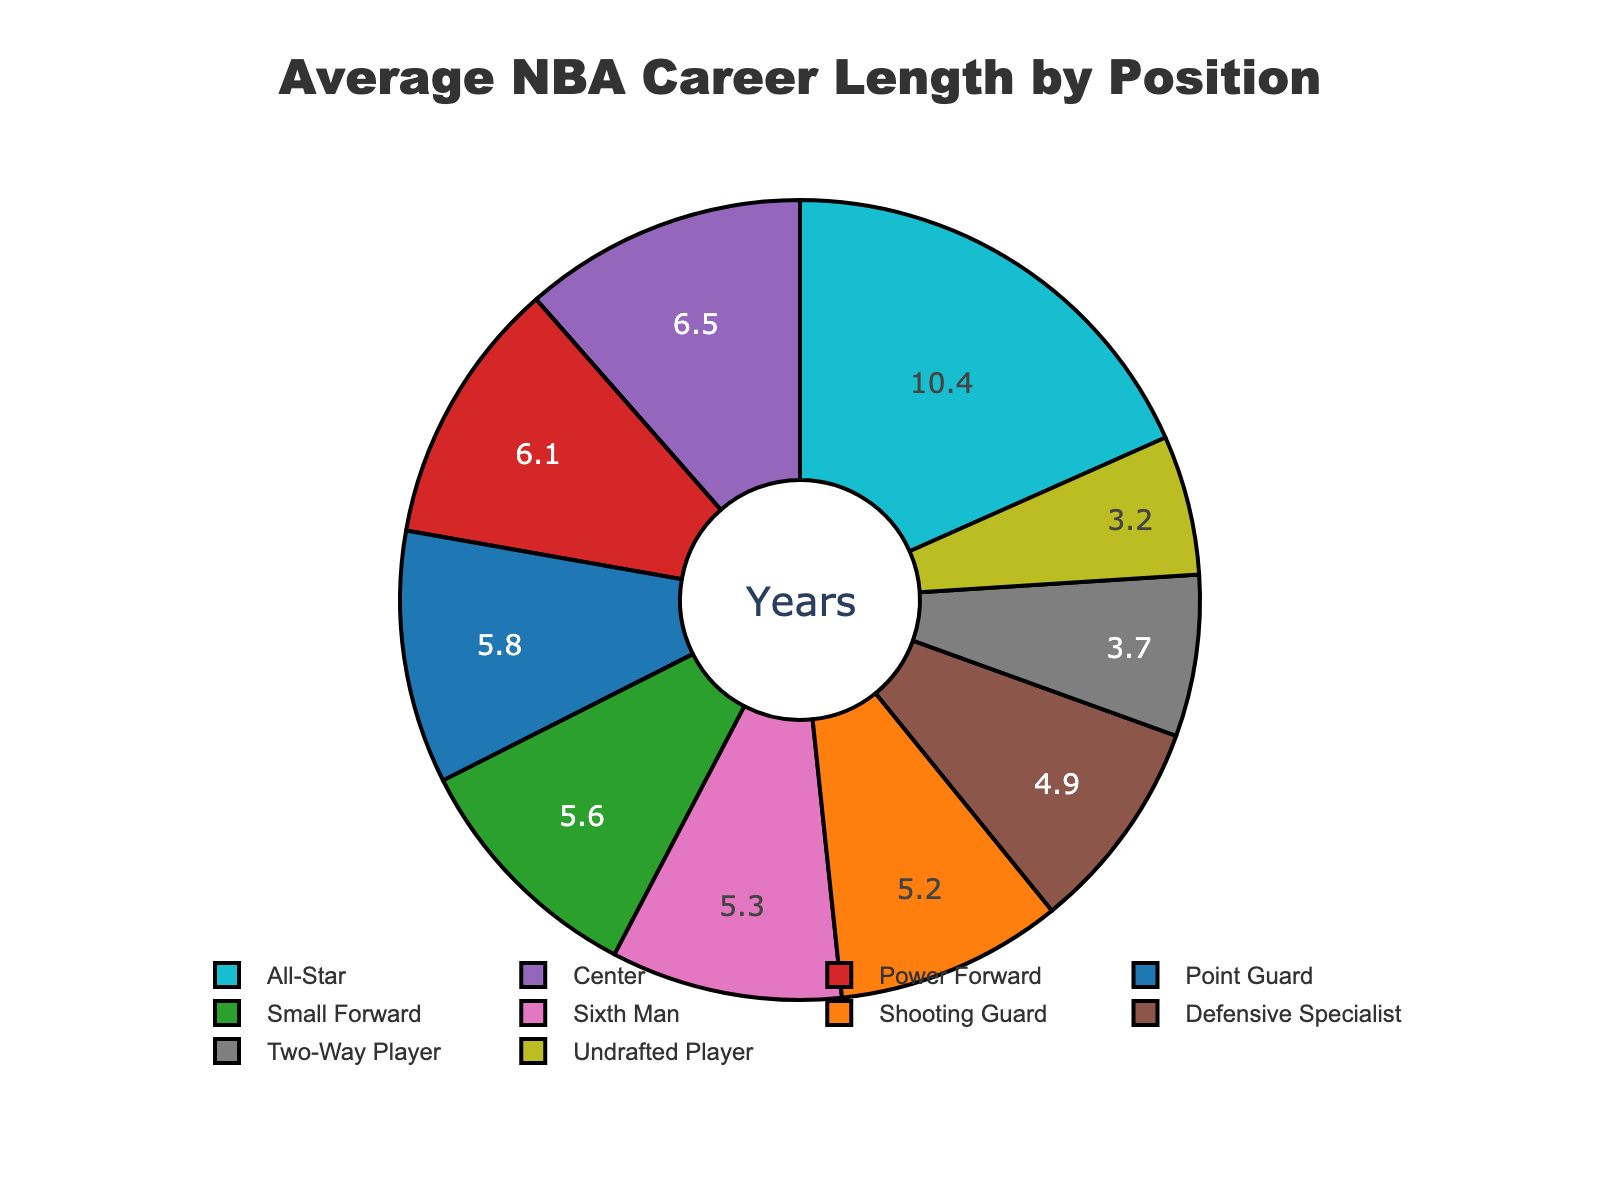What position has the longest average career length? The "Center" position shows the highest value on the pie chart slice. Thus, they have the longest average career length.
Answer: Center Which two positions combined have an average career length closest to that of All-Stars? We need to find two positions whose combined average career lengths total close to 10.4 years. Point Guard (5.8) and Shooting Guard (5.2) total 11.0, which is closest to 10.4.
Answer: Point Guard and Shooting Guard How much shorter is the average career length of an undrafted player compared to an All-Star? The value for Undrafted Player is 3.2 years, and for All-Star it’s 10.4 years. The difference is 10.4 - 3.2.
Answer: 7.2 years What colors represent the career lengths of Small Forward and Power Forward? The slice for Small Forward is colored in green, while the slice for Power Forward is colored in red.
Answer: Green and Red Which position has a shorter average career length: Sixth Man or Two-Way Player? The slice for Two-Way Player is smaller than that for Sixth Man. Therefore, Two-Way Player has a shorter career length.
Answer: Two-Way Player How many positions have an average career length greater than 5 years? The positions with career lengths greater than 5 years are Point Guard (5.8), Small Forward (5.6), Power Forward (6.1), Center (6.5), and All-Star (10.4). There are 5 such positions.
Answer: 5 positions What is the difference in average career length between Defensive Specialist and Point Guard? The values for Defensive Specialist and Point Guard are 4.9 and 5.8 years respectively. The difference is 5.8 - 4.9.
Answer: 0.9 years Does any position have a career length exactly half that of an All-Star? Half of 10.4 years is 5.2 years. Shooting Guard has an average career length of exactly 5.2 years.
Answer: Yes, Shooting Guard 